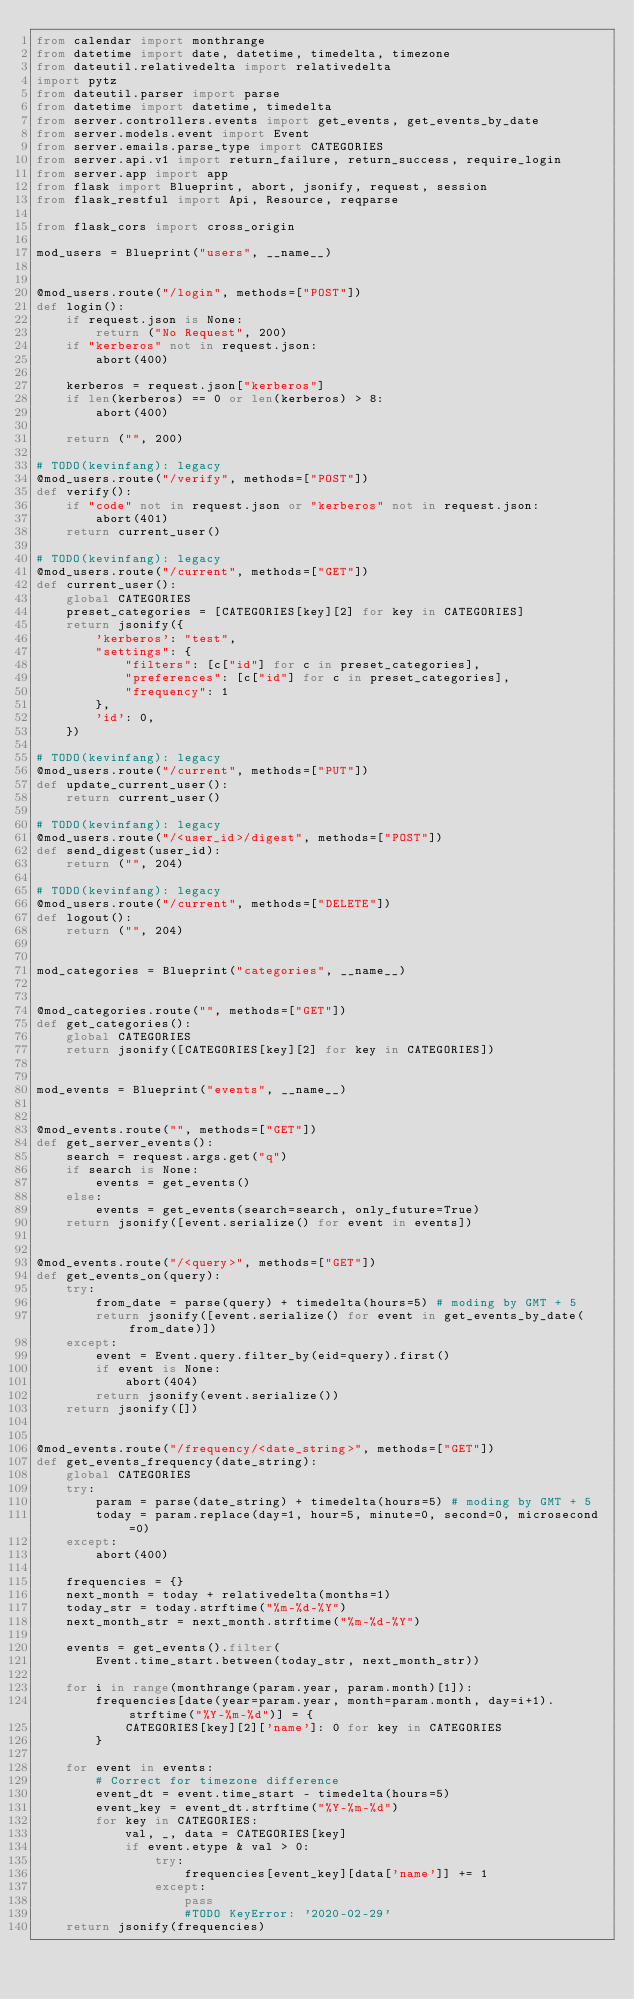Convert code to text. <code><loc_0><loc_0><loc_500><loc_500><_Python_>from calendar import monthrange
from datetime import date, datetime, timedelta, timezone
from dateutil.relativedelta import relativedelta
import pytz
from dateutil.parser import parse
from datetime import datetime, timedelta
from server.controllers.events import get_events, get_events_by_date
from server.models.event import Event
from server.emails.parse_type import CATEGORIES
from server.api.v1 import return_failure, return_success, require_login
from server.app import app
from flask import Blueprint, abort, jsonify, request, session
from flask_restful import Api, Resource, reqparse

from flask_cors import cross_origin

mod_users = Blueprint("users", __name__)


@mod_users.route("/login", methods=["POST"])
def login():
    if request.json is None:
        return ("No Request", 200)
    if "kerberos" not in request.json:
        abort(400)

    kerberos = request.json["kerberos"]
    if len(kerberos) == 0 or len(kerberos) > 8:
        abort(400)

    return ("", 200)

# TODO(kevinfang): legacy
@mod_users.route("/verify", methods=["POST"])
def verify():
    if "code" not in request.json or "kerberos" not in request.json:
        abort(401)
    return current_user()

# TODO(kevinfang): legacy
@mod_users.route("/current", methods=["GET"])
def current_user():
    global CATEGORIES
    preset_categories = [CATEGORIES[key][2] for key in CATEGORIES]
    return jsonify({
        'kerberos': "test",
        "settings": {
            "filters": [c["id"] for c in preset_categories],
            "preferences": [c["id"] for c in preset_categories],
            "frequency": 1
        },
        'id': 0,
    })

# TODO(kevinfang): legacy
@mod_users.route("/current", methods=["PUT"])
def update_current_user():
    return current_user()

# TODO(kevinfang): legacy
@mod_users.route("/<user_id>/digest", methods=["POST"])
def send_digest(user_id):
    return ("", 204)

# TODO(kevinfang): legacy
@mod_users.route("/current", methods=["DELETE"])
def logout():
    return ("", 204)


mod_categories = Blueprint("categories", __name__)


@mod_categories.route("", methods=["GET"])
def get_categories():
    global CATEGORIES
    return jsonify([CATEGORIES[key][2] for key in CATEGORIES])


mod_events = Blueprint("events", __name__)


@mod_events.route("", methods=["GET"])
def get_server_events():
    search = request.args.get("q")
    if search is None:
        events = get_events()
    else:
        events = get_events(search=search, only_future=True)
    return jsonify([event.serialize() for event in events])


@mod_events.route("/<query>", methods=["GET"])
def get_events_on(query):
    try:
        from_date = parse(query) + timedelta(hours=5) # moding by GMT + 5
        return jsonify([event.serialize() for event in get_events_by_date(from_date)])
    except:
        event = Event.query.filter_by(eid=query).first()
        if event is None:
            abort(404)
        return jsonify(event.serialize())
    return jsonify([])


@mod_events.route("/frequency/<date_string>", methods=["GET"])
def get_events_frequency(date_string):
    global CATEGORIES
    try:
        param = parse(date_string) + timedelta(hours=5) # moding by GMT + 5
        today = param.replace(day=1, hour=5, minute=0, second=0, microsecond=0)
    except:
        abort(400)

    frequencies = {}
    next_month = today + relativedelta(months=1)
    today_str = today.strftime("%m-%d-%Y")
    next_month_str = next_month.strftime("%m-%d-%Y")

    events = get_events().filter(
        Event.time_start.between(today_str, next_month_str))

    for i in range(monthrange(param.year, param.month)[1]):
        frequencies[date(year=param.year, month=param.month, day=i+1).strftime("%Y-%m-%d")] = {
            CATEGORIES[key][2]['name']: 0 for key in CATEGORIES
        }

    for event in events:
        # Correct for timezone difference
        event_dt = event.time_start - timedelta(hours=5)
        event_key = event_dt.strftime("%Y-%m-%d")
        for key in CATEGORIES:
            val, _, data = CATEGORIES[key]
            if event.etype & val > 0:
                try:
                    frequencies[event_key][data['name']] += 1
                except:
                    pass
                    #TODO KeyError: '2020-02-29'
    return jsonify(frequencies)
</code> 